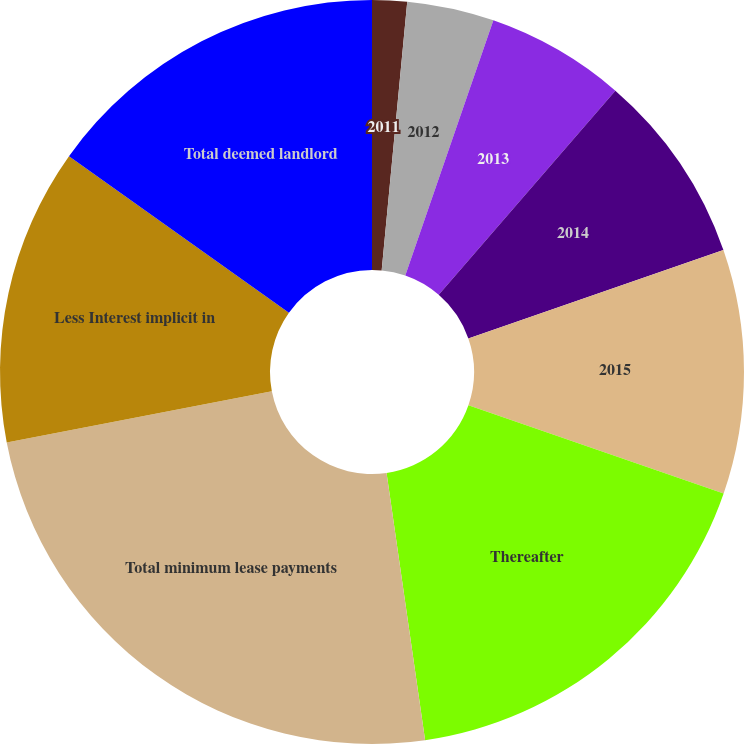Convert chart to OTSL. <chart><loc_0><loc_0><loc_500><loc_500><pie_chart><fcel>2011<fcel>2012<fcel>2013<fcel>2014<fcel>2015<fcel>Thereafter<fcel>Total minimum lease payments<fcel>Less Interest implicit in<fcel>Total deemed landlord<nl><fcel>1.51%<fcel>3.78%<fcel>6.06%<fcel>8.33%<fcel>10.61%<fcel>17.43%<fcel>24.25%<fcel>12.88%<fcel>15.15%<nl></chart> 